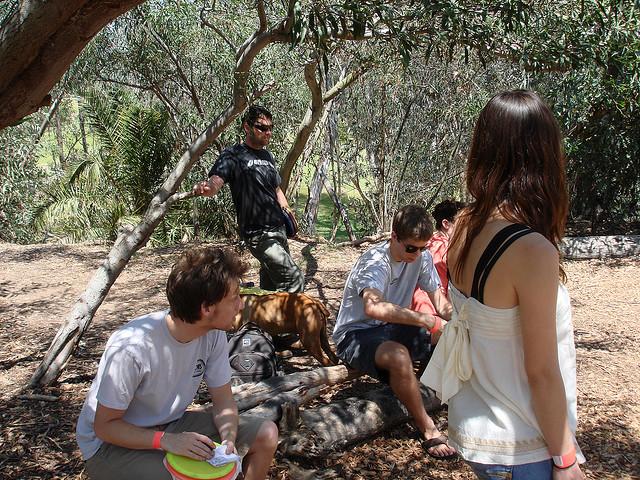What are they standing in front of?
Give a very brief answer. Tree. Are they holding wine glasses?
Be succinct. No. What is the standing guy leaning on?
Concise answer only. Tree. What is the dog doing?
Be succinct. Standing. How many men are in the picture?
Concise answer only. 3. Is the boy wearing a tie?
Keep it brief. No. 